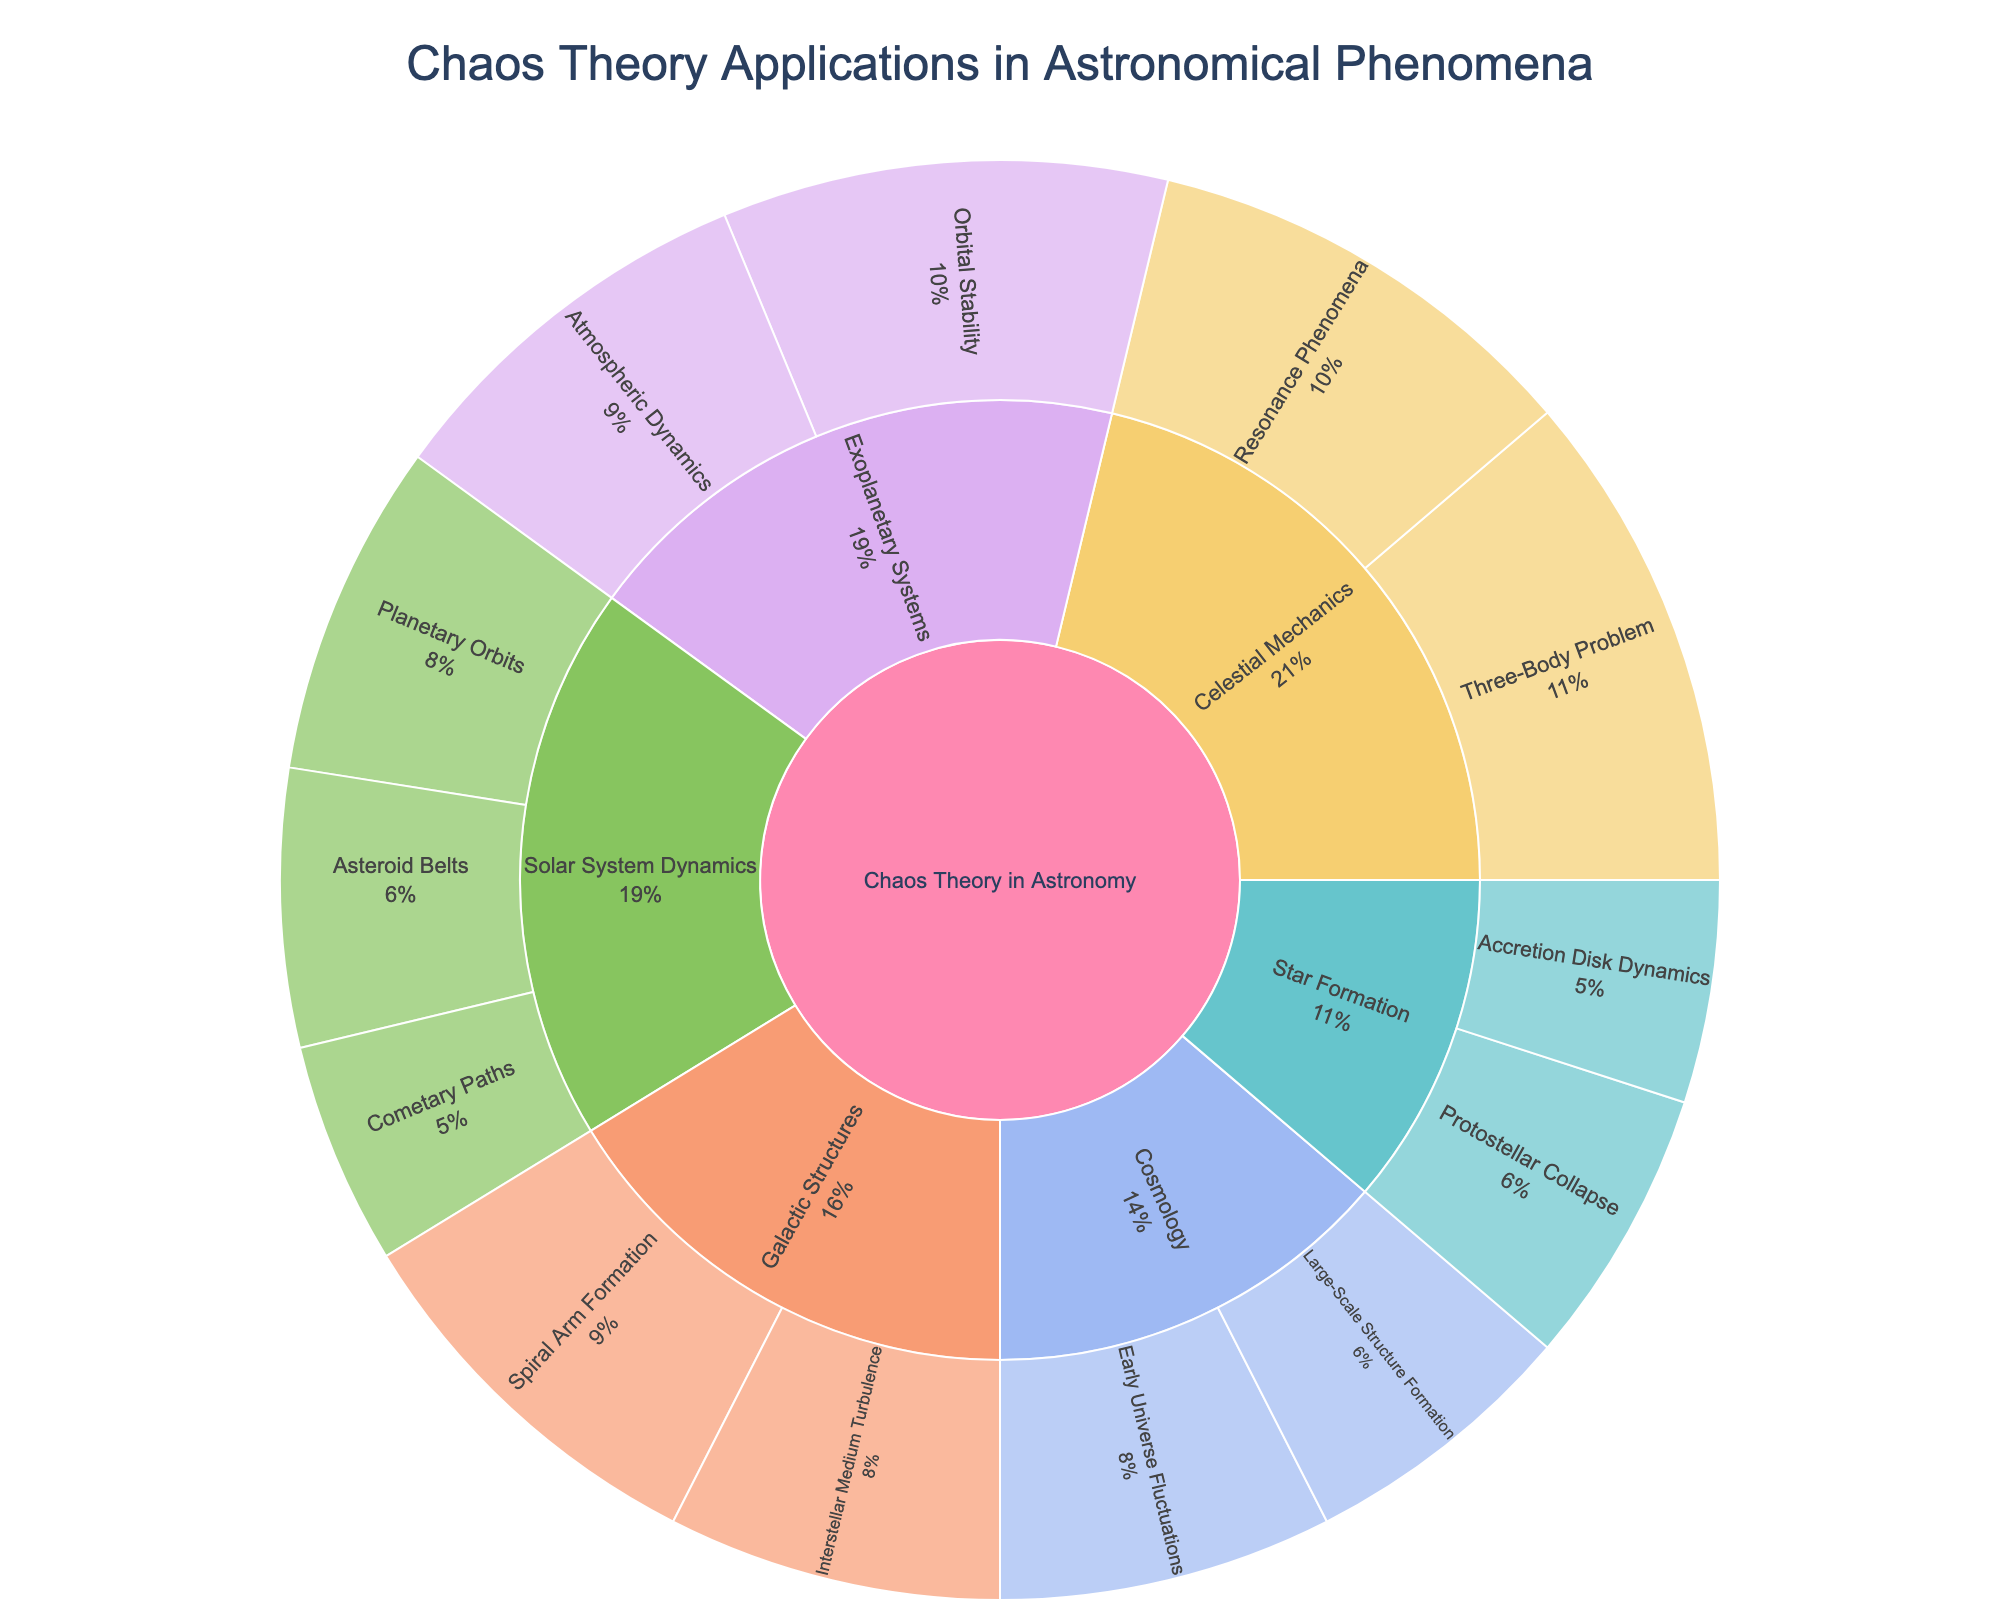How many main categories are presented in the sunburst plot? The figure has five distinct segments emerging directly from the center, each representing a main category.
Answer: 5 Which subcategory under "Solar System Dynamics" has the lowest value? To identify the subcategory with the lowest value, look at the segments branching out from "Solar System Dynamics" and compare the values. "Cometary Paths" has the lowest value at 20.
Answer: Cometary Paths What is the total value for all subcategories under "Exoplanetary Systems"? Sum the values of subcategories under "Exoplanetary Systems". The values for "Orbital Stability" and "Atmospheric Dynamics" are 40 and 35 respectively, totaling 75.
Answer: 75 Which category has the highest cumulative value, and what is that value? Sum the values of all subcategories for each category and compare them. "Celestial Mechanics" has the highest cumulative value with 45 (Three-Body Problem) + 40 (Resonance Phenomena) = 85.
Answer: Celestial Mechanics, 85 How does the value of "Interstellar Medium Turbulence" compare to "Protostellar Collapse"? Compare the values of these two subcategories directly. "Interstellar Medium Turbulence" is 30, while "Protostellar Collapse" is 25, hence "Interstellar Medium Turbulence" has a higher value.
Answer: Interstellar Medium Turbulence has a higher value than Protostellar Collapse If you sum up the values for all subcategories under "Star Formation", what percentage of the total value does it represent across all categories? First calculate the sum of values under "Star Formation": 25 (Protostellar Collapse) + 20 (Accretion Disk Dynamics) = 45. Then calculate the total value of all subcategories: 375. The percentage is (45/375) * 100% = 12%.
Answer: 12% Which subcategory under "Cosmology" has a higher value, and by how much? Compare the values of the subcategories under "Cosmology". "Early Universe Fluctuations" at 30 and "Large-Scale Structure Formation" at 25. The difference is 30 - 25 = 5.
Answer: Early Universe Fluctuations, by 5 Where does "Spiral Arm Formation" fit within the hierarchy of categories in the plot? "Spiral Arm Formation" falls under the category "Galactic Structures," which in turn is under the main category "Chaos Theory in Astronomy."
Answer: Under Galactic Structures, which is under Chaos Theory in Astronomy What percentage of the total value is represented by "Planetary Orbits"? First find the total value of all subcategories (375). Then, percentage is calculated by (30/375) * 100 = 8%.
Answer: 8% Which has a greater value: the sum of "Asteroid Belts" and "Cometary Paths" or the entire value of "Galactic Structures"? Add the values of "Asteroid Belts" (25) and "Cometary Paths" (20) to get 45, which is greater than the individual subcategories but compare to entire "Galactic Structures" sum 35 (Spiral Arm Formation) + 30 (Interstellar Medium Turbulence) = 65.
Answer: Galactic Structures has a greater value 